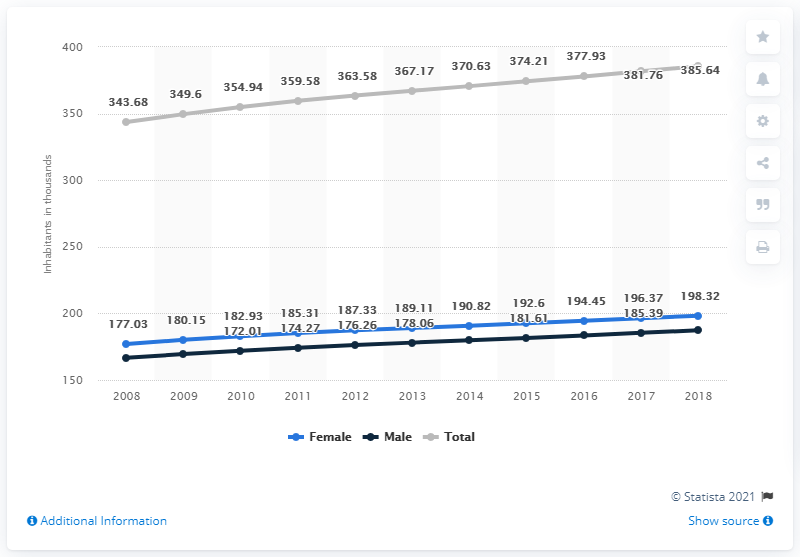How does the male population growth compare to the female growth from 2008 to 2018? From 2008 to 2018, both male and female populations have increased, but the rate of growth shows variation. The male population increased from about 177.03 million to 196.37 million. Meanwhile, the female population, starting slightly lower, rose from 177.03 million to end slightly higher at 198.32 million in 2018. This indicates a slightly faster growth rate for the female population over this decade. 